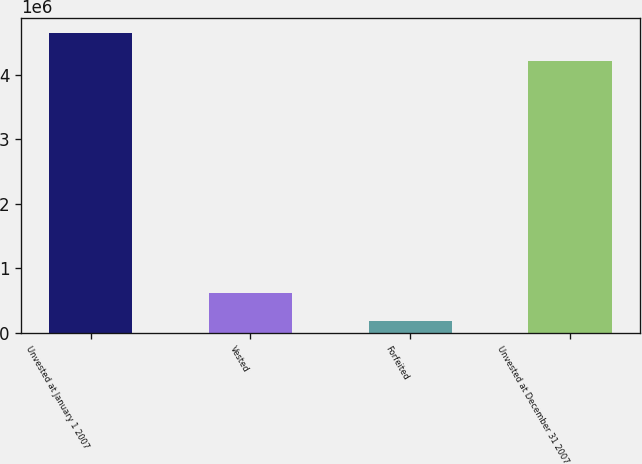<chart> <loc_0><loc_0><loc_500><loc_500><bar_chart><fcel>Unvested at January 1 2007<fcel>Vested<fcel>Forfeited<fcel>Unvested at December 31 2007<nl><fcel>4.66218e+06<fcel>615187<fcel>173472<fcel>4.22046e+06<nl></chart> 